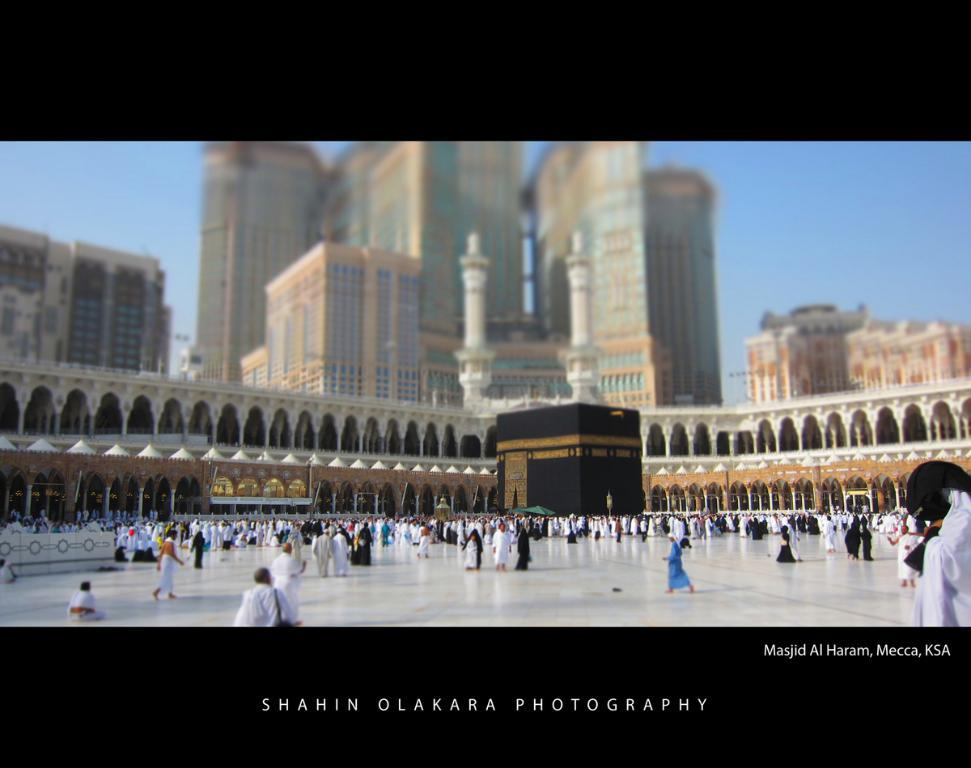What are the people in the image doing? The people in the image are walking. On what surface are the people walking? The people are walking on a floor. What can be seen in the background of the image? There are buildings and the sky visible in the background of the image. Is there any text present in the image? Yes, there is some text on the bottom of the image. Can you tell me how many passengers are riding the donkey in the image? There is no donkey or passengers present in the image. 